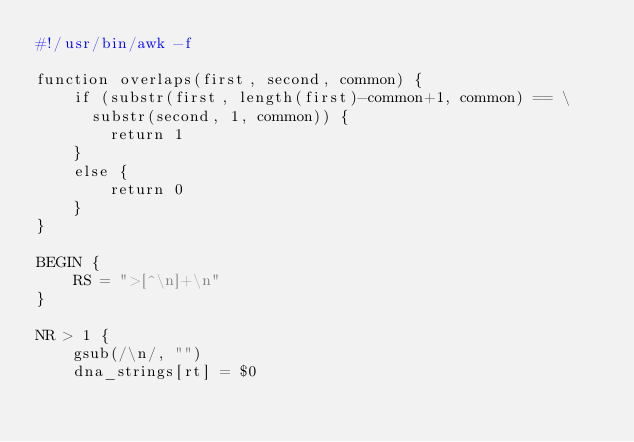<code> <loc_0><loc_0><loc_500><loc_500><_Awk_>#!/usr/bin/awk -f

function overlaps(first, second, common) {
    if (substr(first, length(first)-common+1, common) == \
      substr(second, 1, common)) {
        return 1
    }
    else {
        return 0
    }
}

BEGIN {
    RS = ">[^\n]+\n"
}

NR > 1 {
    gsub(/\n/, "")
    dna_strings[rt] = $0</code> 